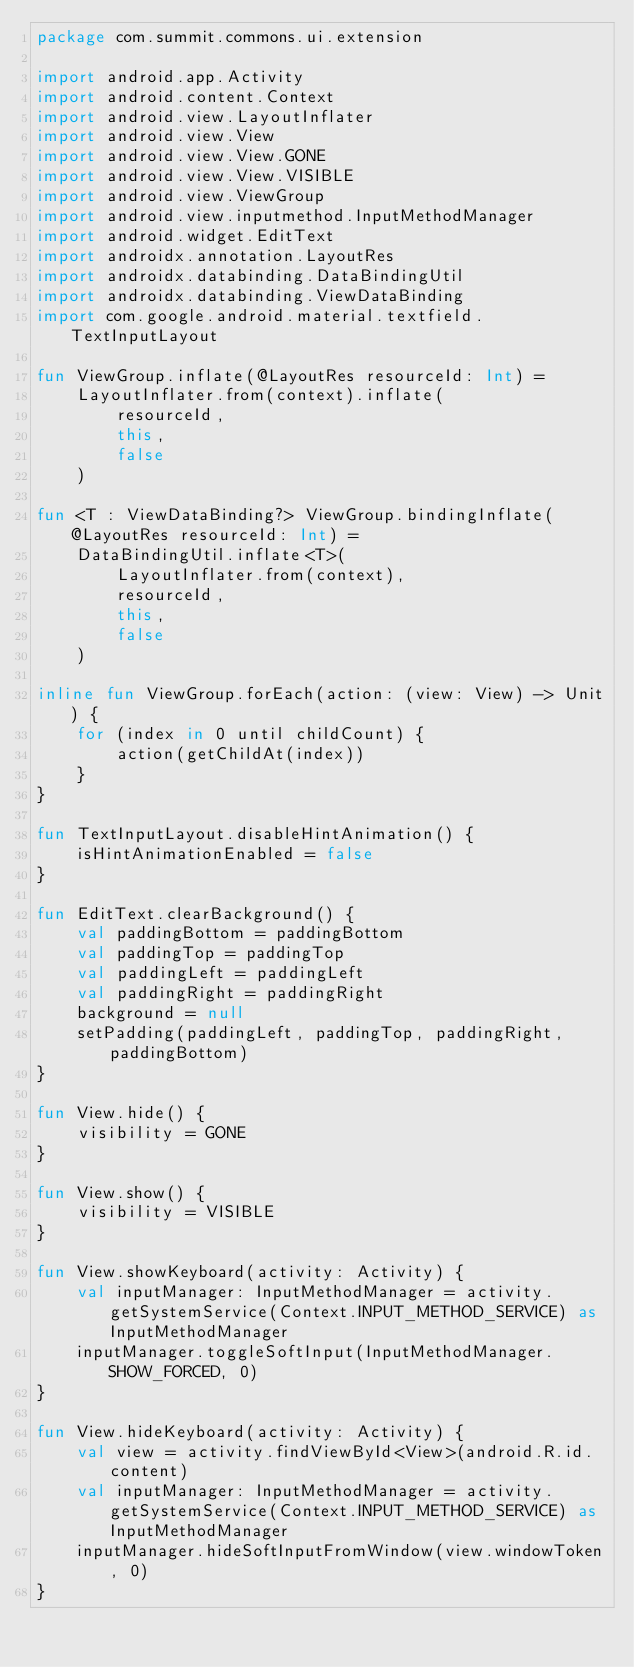<code> <loc_0><loc_0><loc_500><loc_500><_Kotlin_>package com.summit.commons.ui.extension

import android.app.Activity
import android.content.Context
import android.view.LayoutInflater
import android.view.View
import android.view.View.GONE
import android.view.View.VISIBLE
import android.view.ViewGroup
import android.view.inputmethod.InputMethodManager
import android.widget.EditText
import androidx.annotation.LayoutRes
import androidx.databinding.DataBindingUtil
import androidx.databinding.ViewDataBinding
import com.google.android.material.textfield.TextInputLayout

fun ViewGroup.inflate(@LayoutRes resourceId: Int) =
    LayoutInflater.from(context).inflate(
        resourceId,
        this,
        false
    )

fun <T : ViewDataBinding?> ViewGroup.bindingInflate(@LayoutRes resourceId: Int) =
    DataBindingUtil.inflate<T>(
        LayoutInflater.from(context),
        resourceId,
        this,
        false
    )

inline fun ViewGroup.forEach(action: (view: View) -> Unit) {
    for (index in 0 until childCount) {
        action(getChildAt(index))
    }
}

fun TextInputLayout.disableHintAnimation() {
    isHintAnimationEnabled = false
}

fun EditText.clearBackground() {
    val paddingBottom = paddingBottom
    val paddingTop = paddingTop
    val paddingLeft = paddingLeft
    val paddingRight = paddingRight
    background = null
    setPadding(paddingLeft, paddingTop, paddingRight, paddingBottom)
}

fun View.hide() {
    visibility = GONE
}

fun View.show() {
    visibility = VISIBLE
}

fun View.showKeyboard(activity: Activity) {
    val inputManager: InputMethodManager = activity.getSystemService(Context.INPUT_METHOD_SERVICE) as InputMethodManager
    inputManager.toggleSoftInput(InputMethodManager.SHOW_FORCED, 0)
}

fun View.hideKeyboard(activity: Activity) {
    val view = activity.findViewById<View>(android.R.id.content)
    val inputManager: InputMethodManager = activity.getSystemService(Context.INPUT_METHOD_SERVICE) as InputMethodManager
    inputManager.hideSoftInputFromWindow(view.windowToken, 0)
}
</code> 